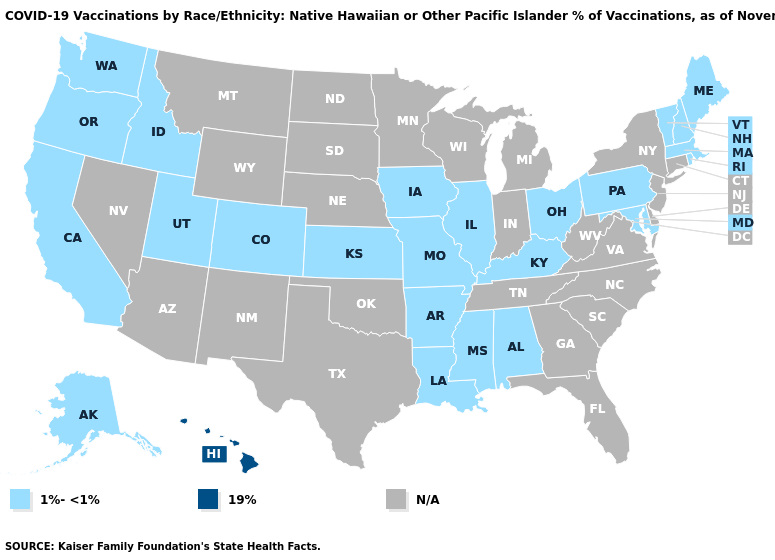Name the states that have a value in the range 1%-<1%?
Short answer required. Alabama, Alaska, Arkansas, California, Colorado, Idaho, Illinois, Iowa, Kansas, Kentucky, Louisiana, Maine, Maryland, Massachusetts, Mississippi, Missouri, New Hampshire, Ohio, Oregon, Pennsylvania, Rhode Island, Utah, Vermont, Washington. Which states hav the highest value in the South?
Short answer required. Alabama, Arkansas, Kentucky, Louisiana, Maryland, Mississippi. Among the states that border Colorado , which have the lowest value?
Quick response, please. Kansas, Utah. Which states have the lowest value in the USA?
Keep it brief. Alabama, Alaska, Arkansas, California, Colorado, Idaho, Illinois, Iowa, Kansas, Kentucky, Louisiana, Maine, Maryland, Massachusetts, Mississippi, Missouri, New Hampshire, Ohio, Oregon, Pennsylvania, Rhode Island, Utah, Vermont, Washington. Name the states that have a value in the range N/A?
Write a very short answer. Arizona, Connecticut, Delaware, Florida, Georgia, Indiana, Michigan, Minnesota, Montana, Nebraska, Nevada, New Jersey, New Mexico, New York, North Carolina, North Dakota, Oklahoma, South Carolina, South Dakota, Tennessee, Texas, Virginia, West Virginia, Wisconsin, Wyoming. Name the states that have a value in the range 1%-<1%?
Give a very brief answer. Alabama, Alaska, Arkansas, California, Colorado, Idaho, Illinois, Iowa, Kansas, Kentucky, Louisiana, Maine, Maryland, Massachusetts, Mississippi, Missouri, New Hampshire, Ohio, Oregon, Pennsylvania, Rhode Island, Utah, Vermont, Washington. What is the value of Oregon?
Concise answer only. 1%-<1%. What is the value of Alabama?
Short answer required. 1%-<1%. Does Colorado have the highest value in the West?
Keep it brief. No. What is the highest value in states that border Maryland?
Quick response, please. 1%-<1%. 